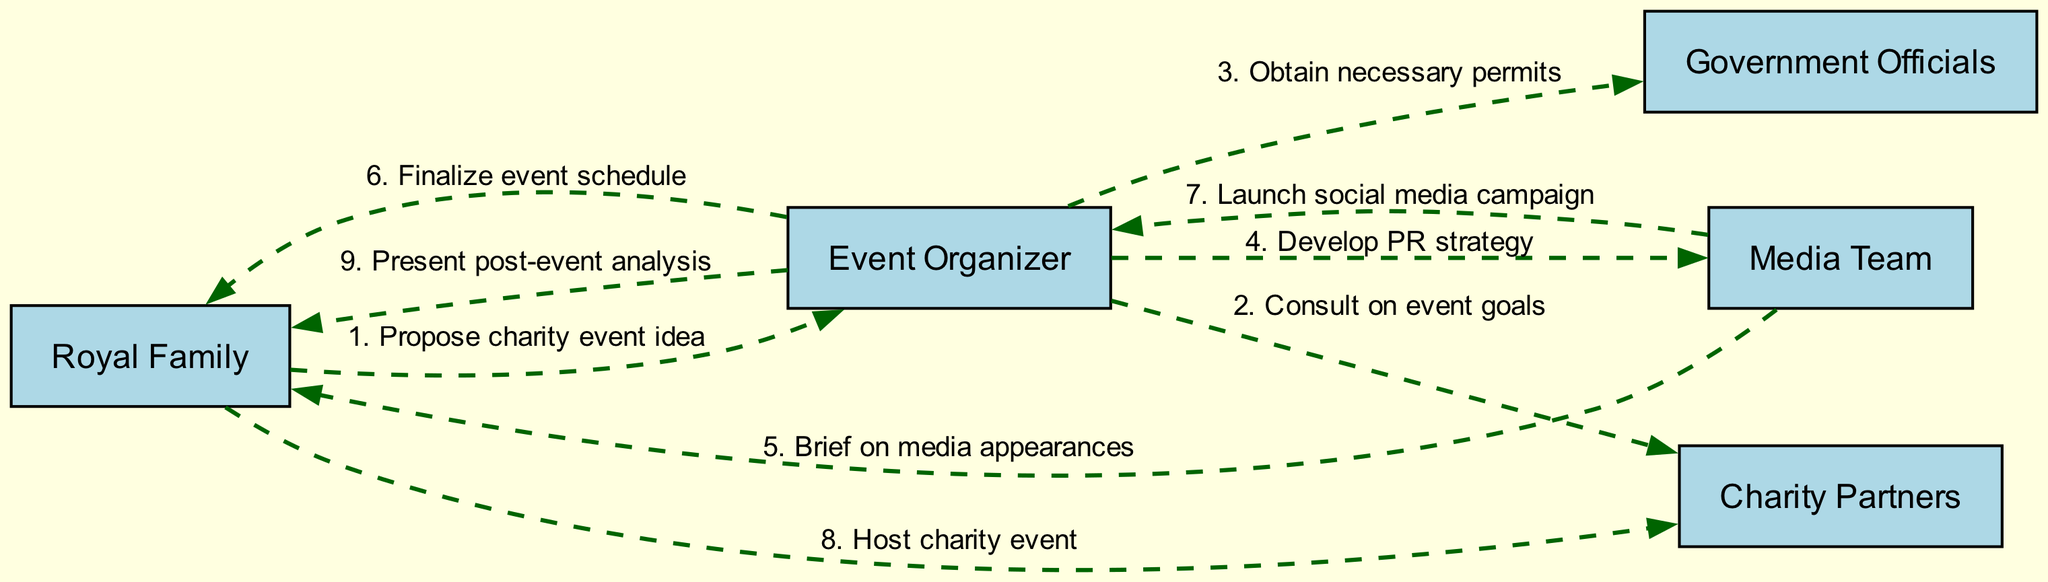What is the first action in the sequence? The first action in the sequence is "Propose charity event idea" initiated by the Royal Family. It appears at the top of the diagram as the starting point of the series of interactions.
Answer: Propose charity event idea How many actors are involved in this sequence? There are five actors listed in the diagram: Royal Family, Event Organizer, Media Team, Charity Partners, and Government Officials. These actors are key participants in the planning and execution of the charity event.
Answer: 5 Which actor is responsible for obtaining necessary permits? The Event Organizer is tasked with obtaining necessary permits as shown by the directed edge from Event Organizer to Government Officials in the diagram.
Answer: Event Organizer What does the Media Team do after developing the PR strategy? After developing the PR strategy, the Media Team launches a social media campaign as indicated by the sequence flow leading from Media Team to Event Organizer.
Answer: Launch social media campaign Which two actors are connected by the action of hosting the charity event? The Royal Family and Charity Partners are connected by the action "Host charity event," where the Royal Family takes the lead in hosting and the Charity Partners presumably participate or benefit from it.
Answer: Royal Family, Charity Partners What is the final action performed in the event sequence? The final action in the sequence is "Present post-event analysis," which flows from the Event Organizer back to the Royal Family. This indicates a reflection on the event's outcomes after it has concluded.
Answer: Present post-event analysis Who briefs the Royal Family on media appearances? The Media Team briefs the Royal Family on media appearances, as shown by the directed edge from Media Team to Royal Family in the diagram, which outlines their communication role.
Answer: Media Team How do the Royal Family and the Event Organizer interact after the charity event? After the charity event, the Event Organizer presents a post-event analysis to the Royal Family, indicating a follow-up interaction focused on evaluating the event's success.
Answer: Present post-event analysis 